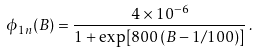Convert formula to latex. <formula><loc_0><loc_0><loc_500><loc_500>\phi _ { 1 n } ( B ) = \frac { 4 \times 1 0 ^ { - 6 } } { 1 + \exp [ 8 0 0 \, ( B - 1 / 1 0 0 ) ] } \, .</formula> 